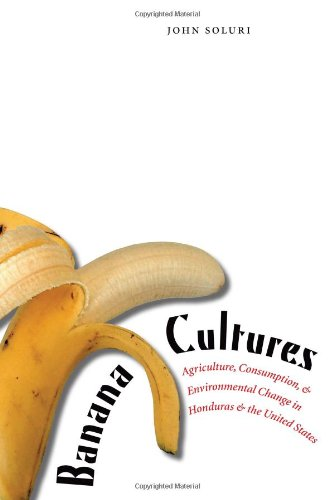Who is the author of this book? The author of the book depicted in the image is John Soluri, who has extensively explored environmental and agricultural changes in particular regions. 